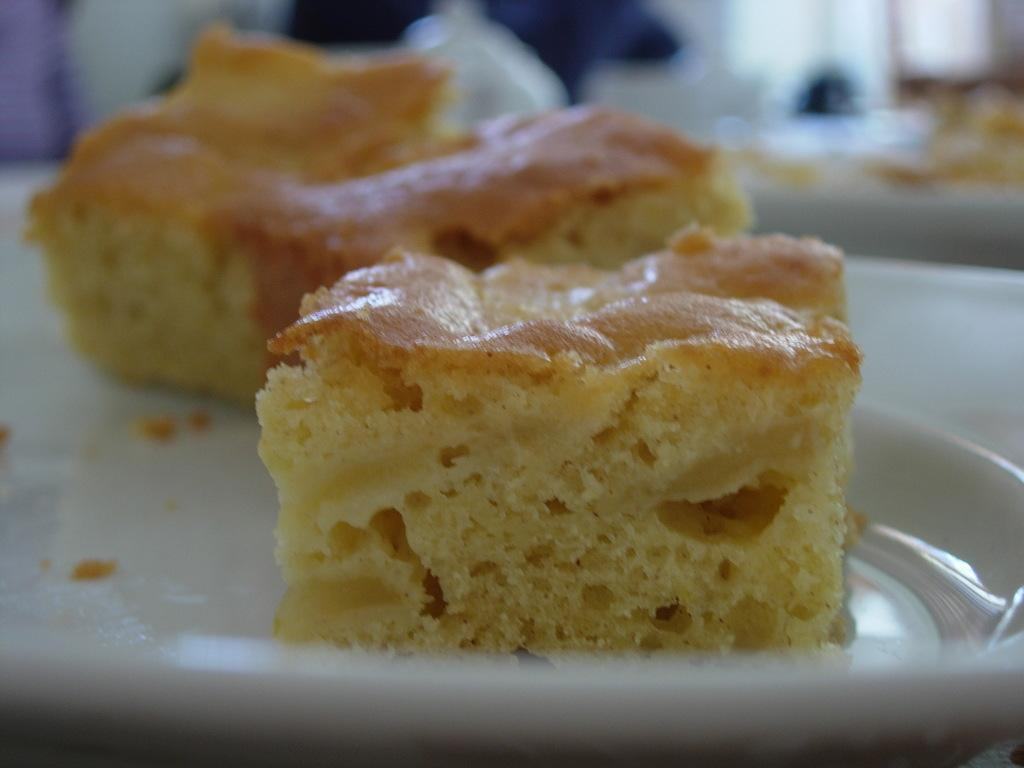What is the color of the plate in the image? The plate in the image is white. What is on the plate? There are cake pieces on the plate. What is the name of the boy who is touching the cake pieces in the image? There is no boy present in the image, and the cake pieces are on a plate, not being touched by anyone. 